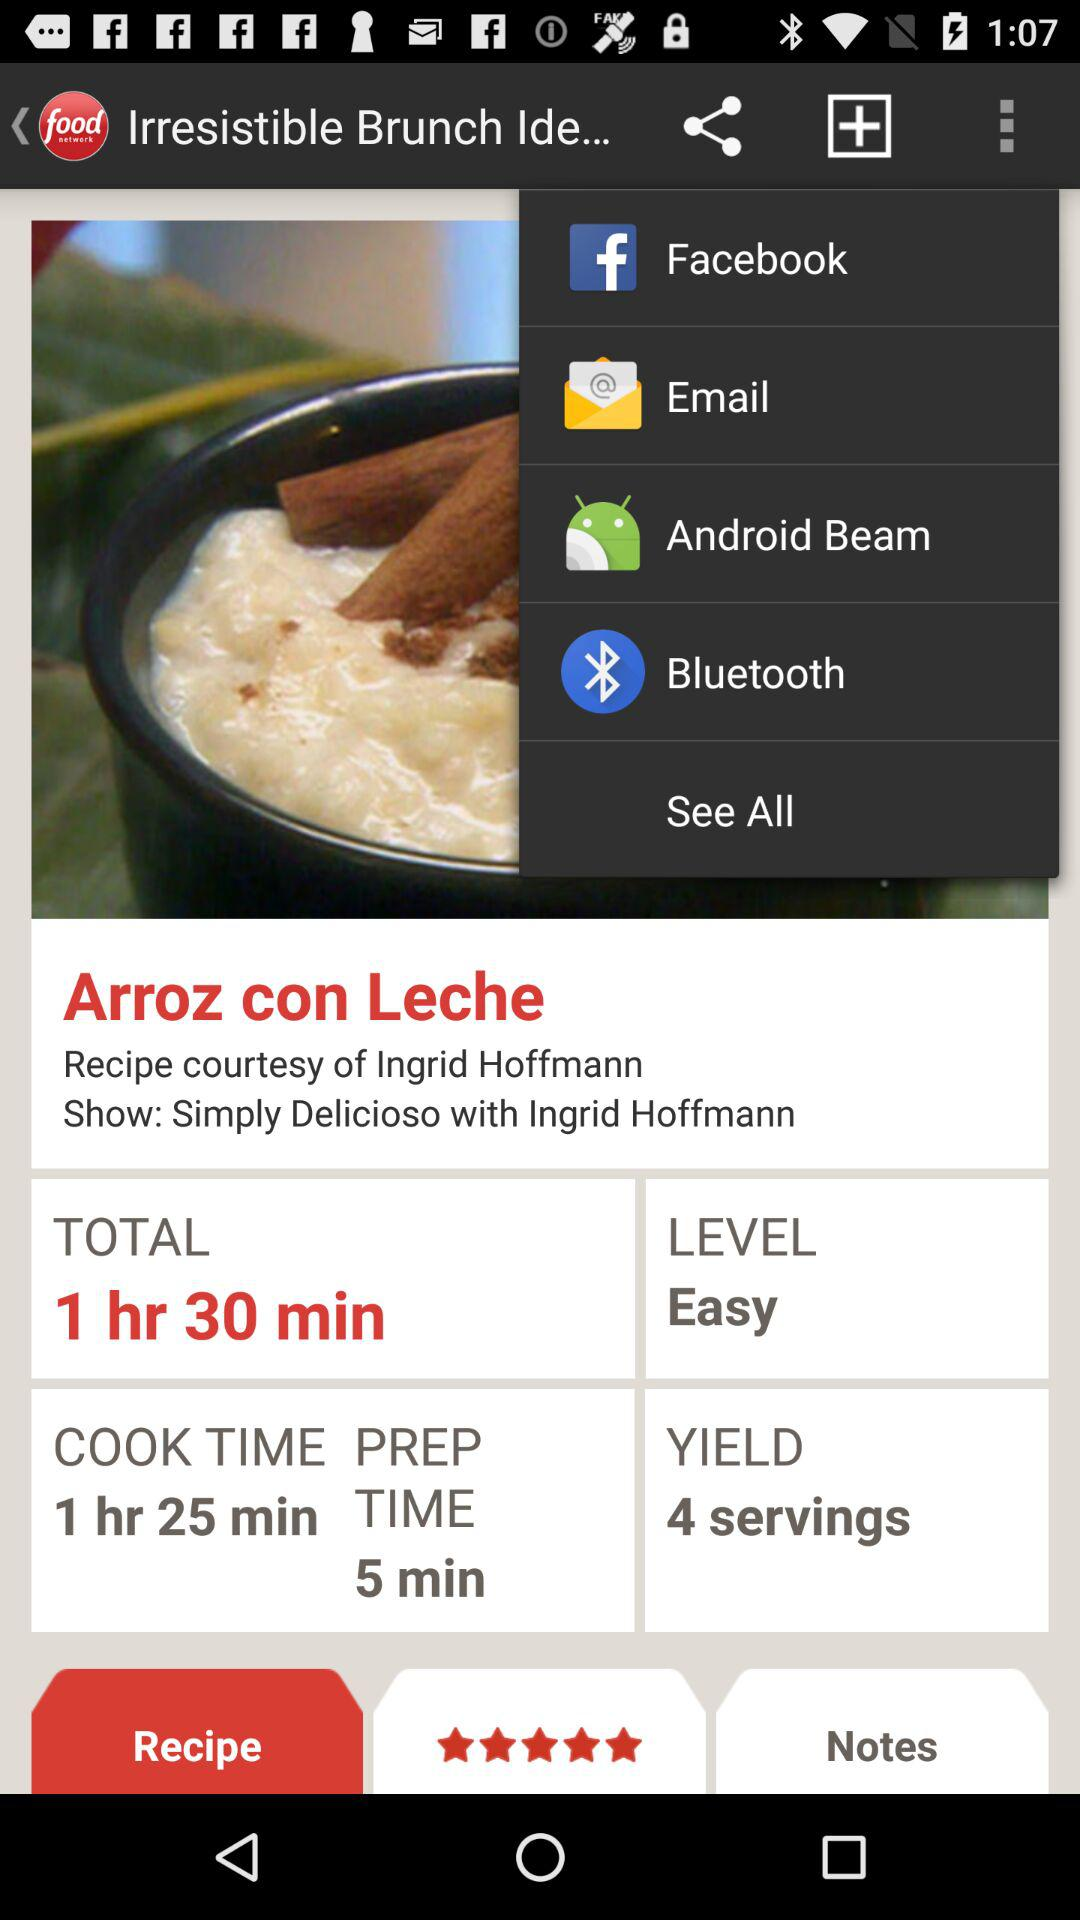How many servings are there in a yield? There are 4 servings. 